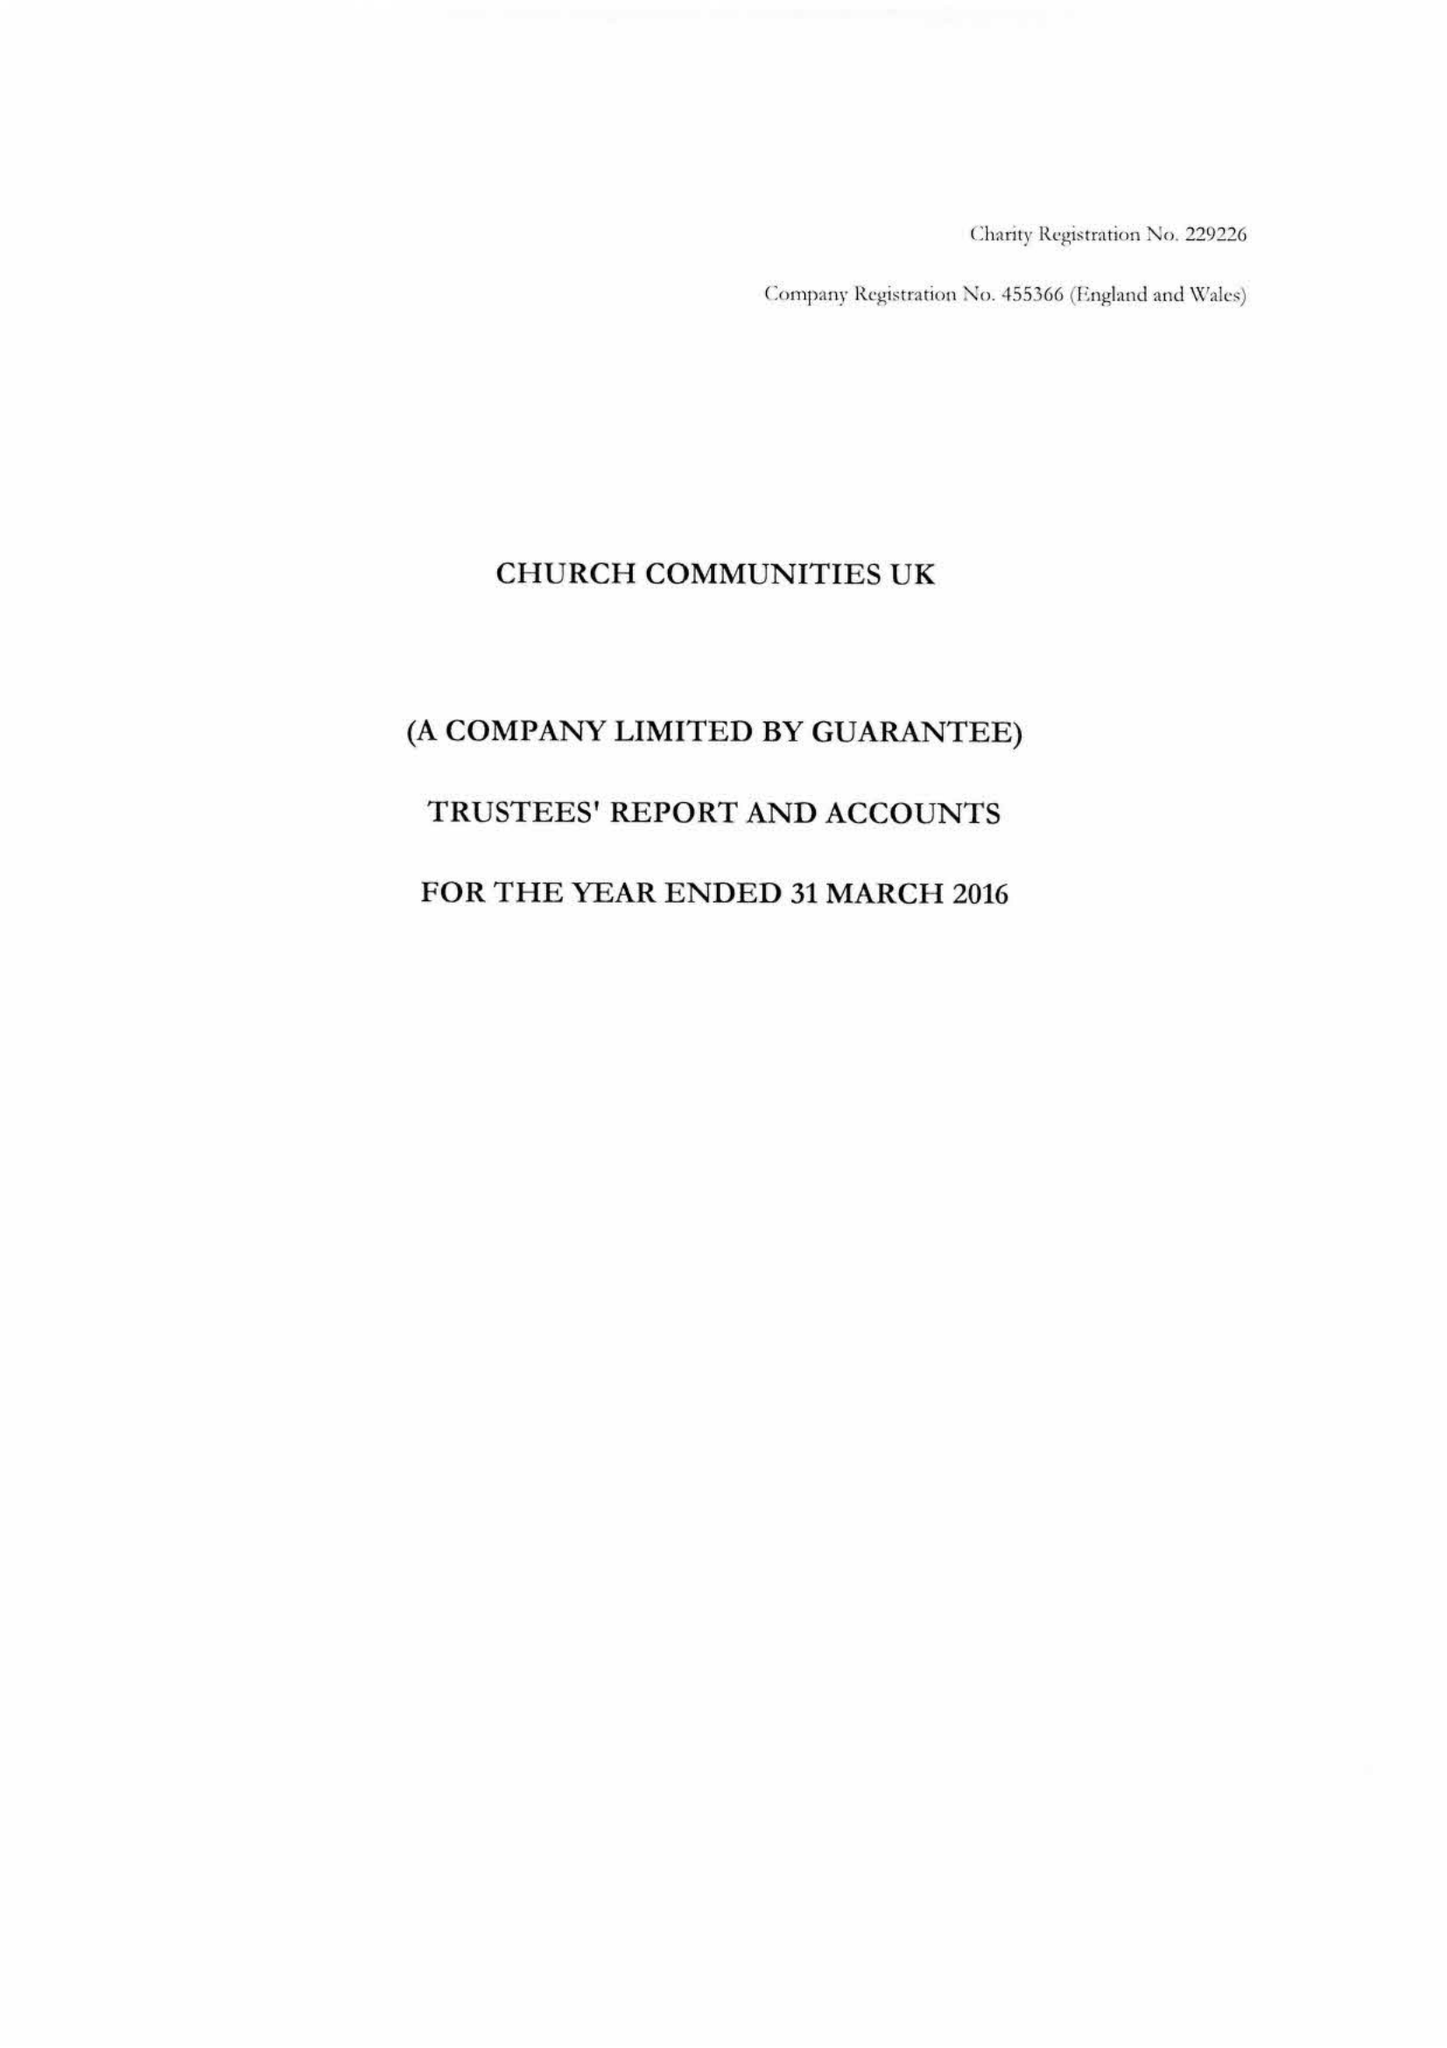What is the value for the address__post_town?
Answer the question using a single word or phrase. ROBERTSBRIDGE 